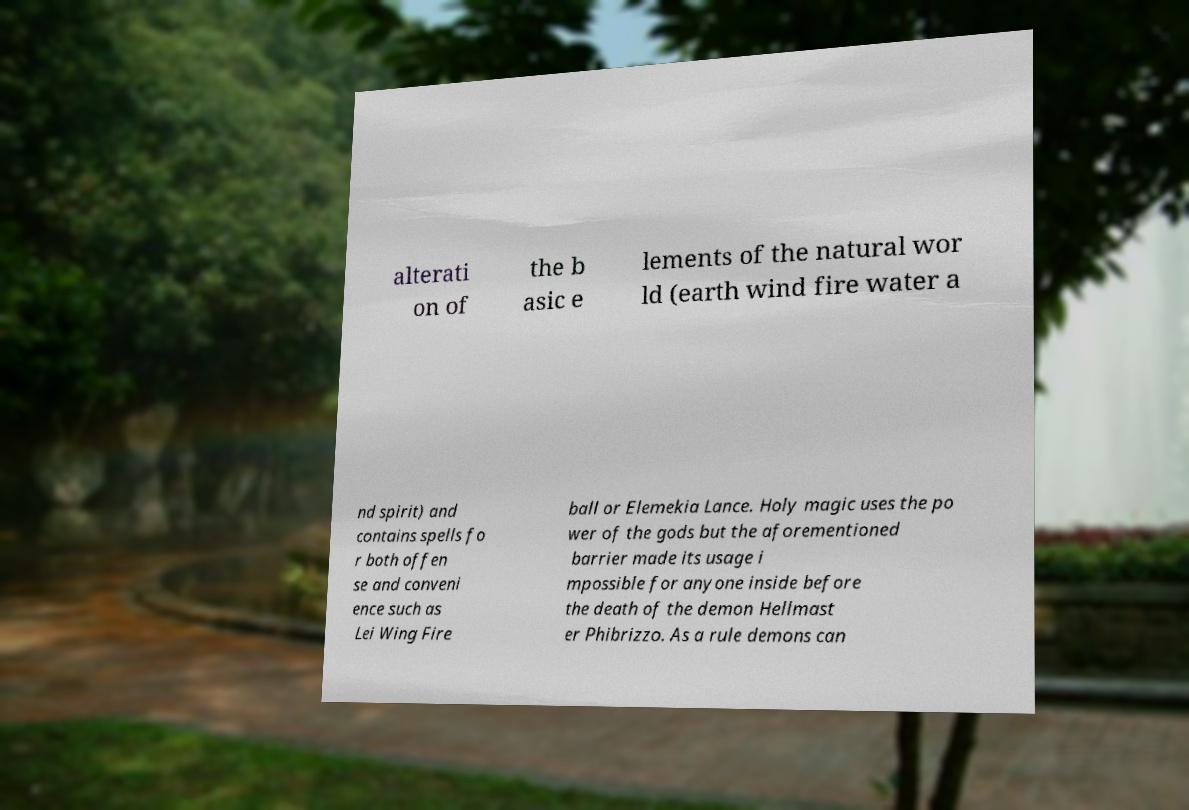I need the written content from this picture converted into text. Can you do that? alterati on of the b asic e lements of the natural wor ld (earth wind fire water a nd spirit) and contains spells fo r both offen se and conveni ence such as Lei Wing Fire ball or Elemekia Lance. Holy magic uses the po wer of the gods but the aforementioned barrier made its usage i mpossible for anyone inside before the death of the demon Hellmast er Phibrizzo. As a rule demons can 